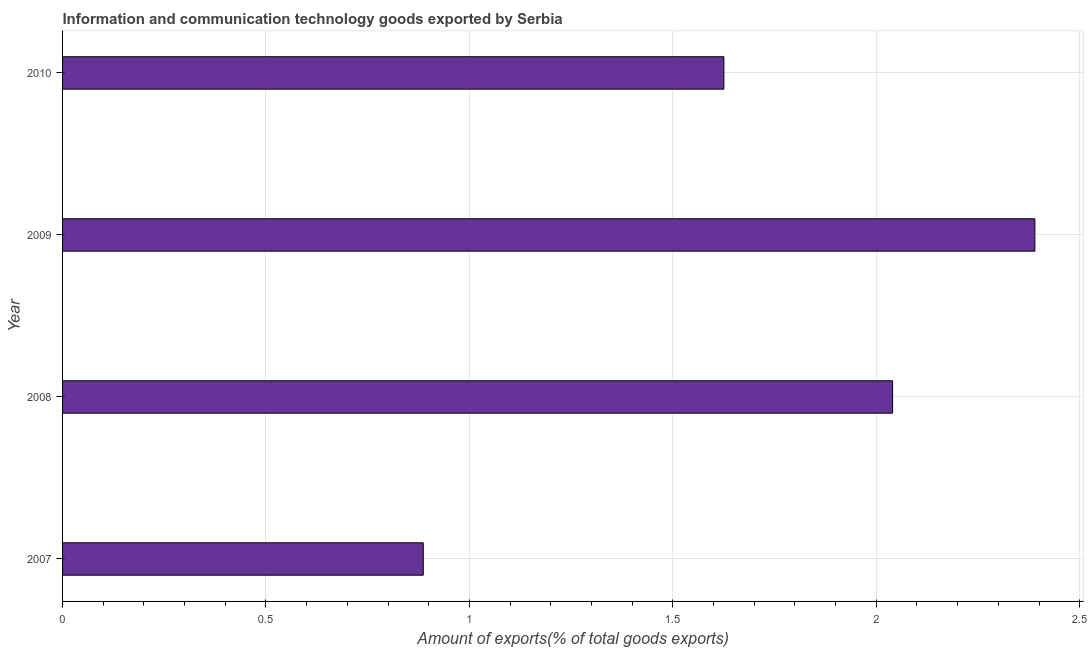What is the title of the graph?
Provide a succinct answer. Information and communication technology goods exported by Serbia. What is the label or title of the X-axis?
Provide a short and direct response. Amount of exports(% of total goods exports). What is the amount of ict goods exports in 2008?
Ensure brevity in your answer.  2.04. Across all years, what is the maximum amount of ict goods exports?
Your answer should be compact. 2.39. Across all years, what is the minimum amount of ict goods exports?
Ensure brevity in your answer.  0.89. In which year was the amount of ict goods exports minimum?
Offer a terse response. 2007. What is the sum of the amount of ict goods exports?
Your response must be concise. 6.94. What is the difference between the amount of ict goods exports in 2007 and 2010?
Your answer should be very brief. -0.74. What is the average amount of ict goods exports per year?
Your response must be concise. 1.74. What is the median amount of ict goods exports?
Offer a very short reply. 1.83. What is the ratio of the amount of ict goods exports in 2008 to that in 2010?
Offer a terse response. 1.25. Is the amount of ict goods exports in 2007 less than that in 2009?
Make the answer very short. Yes. Is the sum of the amount of ict goods exports in 2007 and 2009 greater than the maximum amount of ict goods exports across all years?
Keep it short and to the point. Yes. What is the difference between the highest and the lowest amount of ict goods exports?
Give a very brief answer. 1.5. In how many years, is the amount of ict goods exports greater than the average amount of ict goods exports taken over all years?
Make the answer very short. 2. Are all the bars in the graph horizontal?
Ensure brevity in your answer.  Yes. How many years are there in the graph?
Offer a terse response. 4. What is the difference between two consecutive major ticks on the X-axis?
Offer a very short reply. 0.5. Are the values on the major ticks of X-axis written in scientific E-notation?
Your answer should be compact. No. What is the Amount of exports(% of total goods exports) in 2007?
Offer a very short reply. 0.89. What is the Amount of exports(% of total goods exports) in 2008?
Provide a succinct answer. 2.04. What is the Amount of exports(% of total goods exports) in 2009?
Offer a terse response. 2.39. What is the Amount of exports(% of total goods exports) of 2010?
Offer a terse response. 1.63. What is the difference between the Amount of exports(% of total goods exports) in 2007 and 2008?
Make the answer very short. -1.15. What is the difference between the Amount of exports(% of total goods exports) in 2007 and 2009?
Give a very brief answer. -1.5. What is the difference between the Amount of exports(% of total goods exports) in 2007 and 2010?
Your answer should be very brief. -0.74. What is the difference between the Amount of exports(% of total goods exports) in 2008 and 2009?
Your answer should be very brief. -0.35. What is the difference between the Amount of exports(% of total goods exports) in 2008 and 2010?
Offer a very short reply. 0.41. What is the difference between the Amount of exports(% of total goods exports) in 2009 and 2010?
Offer a very short reply. 0.76. What is the ratio of the Amount of exports(% of total goods exports) in 2007 to that in 2008?
Ensure brevity in your answer.  0.43. What is the ratio of the Amount of exports(% of total goods exports) in 2007 to that in 2009?
Your answer should be compact. 0.37. What is the ratio of the Amount of exports(% of total goods exports) in 2007 to that in 2010?
Make the answer very short. 0.55. What is the ratio of the Amount of exports(% of total goods exports) in 2008 to that in 2009?
Keep it short and to the point. 0.85. What is the ratio of the Amount of exports(% of total goods exports) in 2008 to that in 2010?
Ensure brevity in your answer.  1.25. What is the ratio of the Amount of exports(% of total goods exports) in 2009 to that in 2010?
Provide a succinct answer. 1.47. 